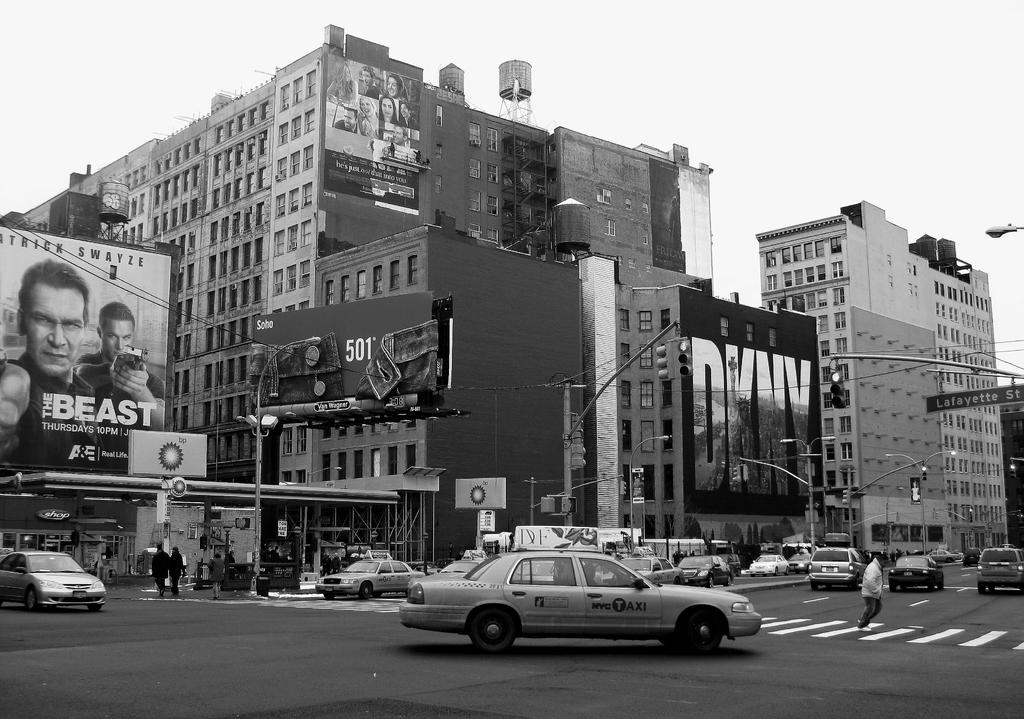<image>
Summarize the visual content of the image. Patrick Swayze stars in the film being advertised on a large billboard. 